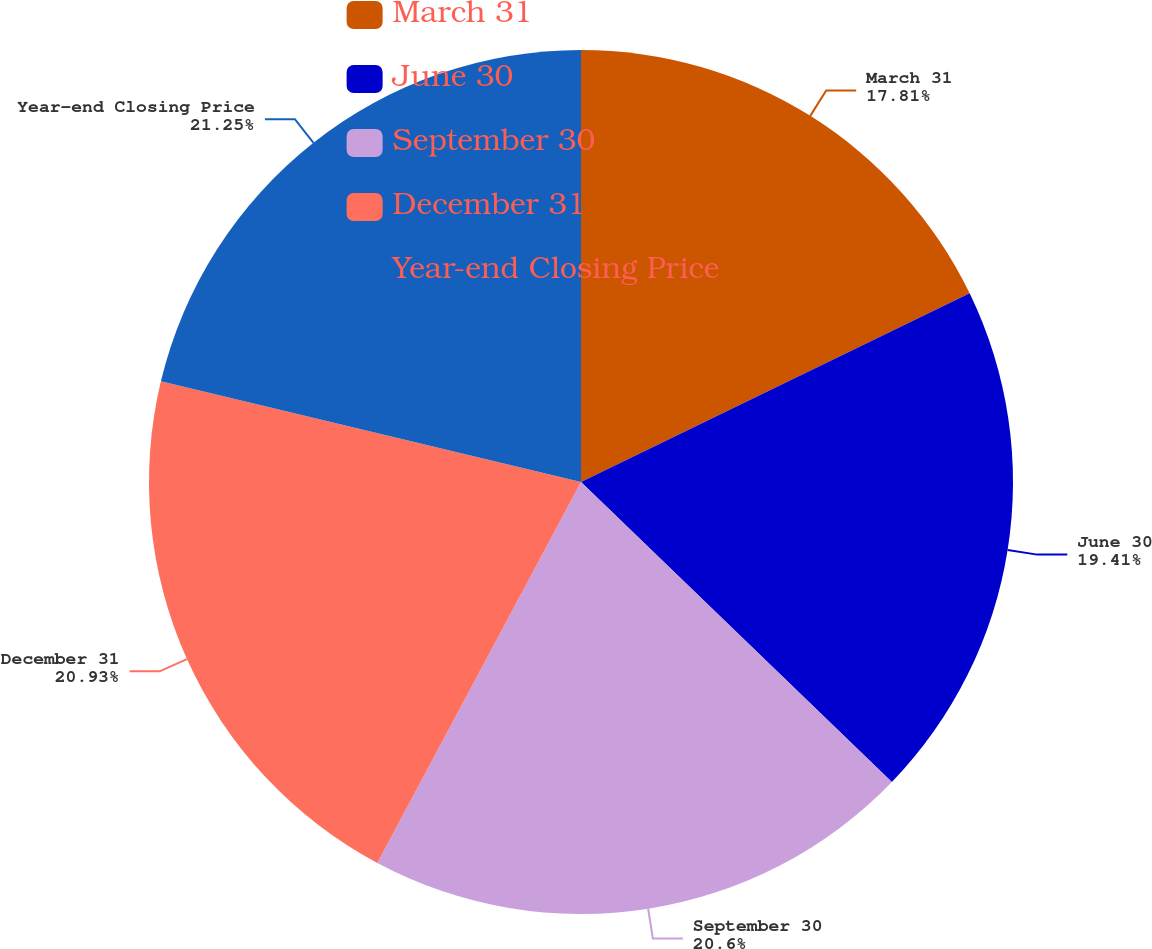<chart> <loc_0><loc_0><loc_500><loc_500><pie_chart><fcel>March 31<fcel>June 30<fcel>September 30<fcel>December 31<fcel>Year-end Closing Price<nl><fcel>17.81%<fcel>19.41%<fcel>20.6%<fcel>20.93%<fcel>21.26%<nl></chart> 